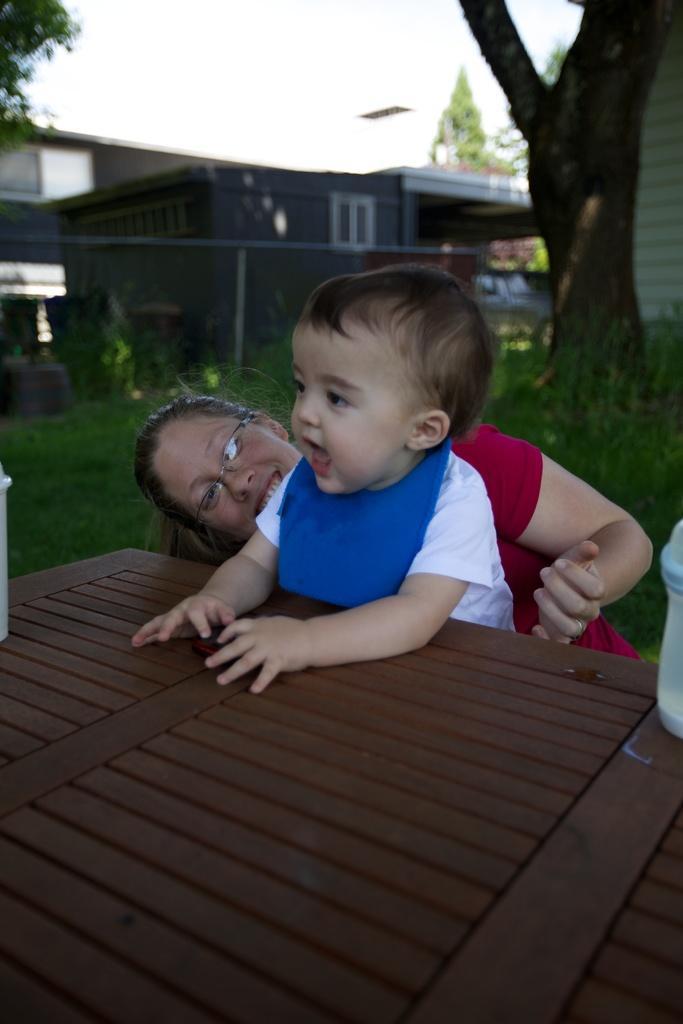Could you give a brief overview of what you see in this image? In the image two persons are there. In front of them there is a table, On the table there is a bottle. Behind them there is a grass and tree. In the middle of the image there is a building. At the top of the image there is a sky. 